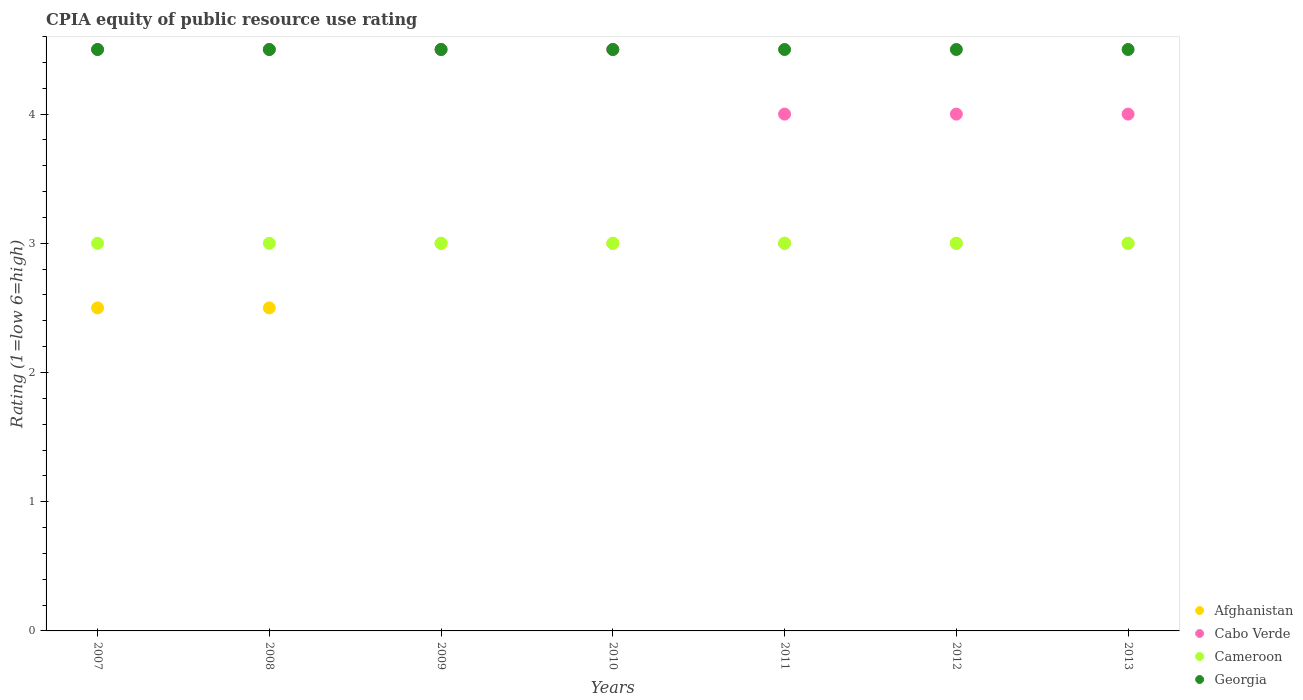How many different coloured dotlines are there?
Keep it short and to the point. 4. What is the CPIA rating in Cameroon in 2012?
Give a very brief answer. 3. Across all years, what is the minimum CPIA rating in Cabo Verde?
Keep it short and to the point. 4. In which year was the CPIA rating in Cameroon maximum?
Your answer should be compact. 2007. In which year was the CPIA rating in Afghanistan minimum?
Provide a short and direct response. 2007. What is the total CPIA rating in Afghanistan in the graph?
Your answer should be very brief. 20. What is the difference between the CPIA rating in Georgia in 2009 and that in 2010?
Your answer should be compact. 0. In the year 2007, what is the difference between the CPIA rating in Georgia and CPIA rating in Cabo Verde?
Give a very brief answer. 0. In how many years, is the CPIA rating in Cameroon greater than 3?
Your response must be concise. 0. What is the ratio of the CPIA rating in Cabo Verde in 2007 to that in 2011?
Provide a succinct answer. 1.12. Is the CPIA rating in Afghanistan in 2009 less than that in 2012?
Provide a succinct answer. No. What is the difference between the highest and the lowest CPIA rating in Cameroon?
Provide a succinct answer. 0. Is it the case that in every year, the sum of the CPIA rating in Cameroon and CPIA rating in Afghanistan  is greater than the CPIA rating in Georgia?
Ensure brevity in your answer.  Yes. Does the CPIA rating in Cameroon monotonically increase over the years?
Your answer should be very brief. No. Is the CPIA rating in Afghanistan strictly less than the CPIA rating in Cabo Verde over the years?
Your answer should be compact. Yes. How many dotlines are there?
Your answer should be compact. 4. How many years are there in the graph?
Make the answer very short. 7. Are the values on the major ticks of Y-axis written in scientific E-notation?
Make the answer very short. No. Does the graph contain any zero values?
Give a very brief answer. No. Does the graph contain grids?
Your answer should be very brief. No. Where does the legend appear in the graph?
Your answer should be very brief. Bottom right. How many legend labels are there?
Your answer should be compact. 4. How are the legend labels stacked?
Offer a very short reply. Vertical. What is the title of the graph?
Provide a short and direct response. CPIA equity of public resource use rating. What is the label or title of the X-axis?
Give a very brief answer. Years. What is the label or title of the Y-axis?
Ensure brevity in your answer.  Rating (1=low 6=high). What is the Rating (1=low 6=high) in Georgia in 2008?
Offer a very short reply. 4.5. What is the Rating (1=low 6=high) in Cabo Verde in 2009?
Provide a succinct answer. 4.5. What is the Rating (1=low 6=high) of Cameroon in 2009?
Give a very brief answer. 3. What is the Rating (1=low 6=high) in Afghanistan in 2010?
Offer a very short reply. 3. What is the Rating (1=low 6=high) of Cameroon in 2010?
Keep it short and to the point. 3. What is the Rating (1=low 6=high) of Cameroon in 2011?
Ensure brevity in your answer.  3. What is the Rating (1=low 6=high) in Cabo Verde in 2012?
Offer a terse response. 4. What is the Rating (1=low 6=high) of Georgia in 2012?
Ensure brevity in your answer.  4.5. What is the Rating (1=low 6=high) in Afghanistan in 2013?
Offer a terse response. 3. What is the Rating (1=low 6=high) in Cabo Verde in 2013?
Offer a terse response. 4. What is the Rating (1=low 6=high) of Cameroon in 2013?
Keep it short and to the point. 3. Across all years, what is the maximum Rating (1=low 6=high) in Cabo Verde?
Offer a terse response. 4.5. Across all years, what is the maximum Rating (1=low 6=high) of Georgia?
Your response must be concise. 4.5. Across all years, what is the minimum Rating (1=low 6=high) in Georgia?
Offer a terse response. 4.5. What is the total Rating (1=low 6=high) in Cabo Verde in the graph?
Ensure brevity in your answer.  30. What is the total Rating (1=low 6=high) of Cameroon in the graph?
Your response must be concise. 21. What is the total Rating (1=low 6=high) in Georgia in the graph?
Provide a succinct answer. 31.5. What is the difference between the Rating (1=low 6=high) in Afghanistan in 2007 and that in 2008?
Provide a short and direct response. 0. What is the difference between the Rating (1=low 6=high) in Cabo Verde in 2007 and that in 2008?
Provide a succinct answer. 0. What is the difference between the Rating (1=low 6=high) in Cameroon in 2007 and that in 2008?
Offer a terse response. 0. What is the difference between the Rating (1=low 6=high) in Cabo Verde in 2007 and that in 2009?
Offer a terse response. 0. What is the difference between the Rating (1=low 6=high) of Cabo Verde in 2007 and that in 2010?
Provide a succinct answer. 0. What is the difference between the Rating (1=low 6=high) of Afghanistan in 2007 and that in 2011?
Your response must be concise. -0.5. What is the difference between the Rating (1=low 6=high) of Cameroon in 2007 and that in 2011?
Ensure brevity in your answer.  0. What is the difference between the Rating (1=low 6=high) of Georgia in 2007 and that in 2012?
Your response must be concise. 0. What is the difference between the Rating (1=low 6=high) in Cameroon in 2007 and that in 2013?
Your answer should be compact. 0. What is the difference between the Rating (1=low 6=high) of Georgia in 2007 and that in 2013?
Offer a very short reply. 0. What is the difference between the Rating (1=low 6=high) in Afghanistan in 2008 and that in 2009?
Your response must be concise. -0.5. What is the difference between the Rating (1=low 6=high) in Cameroon in 2008 and that in 2009?
Make the answer very short. 0. What is the difference between the Rating (1=low 6=high) in Cabo Verde in 2008 and that in 2010?
Ensure brevity in your answer.  0. What is the difference between the Rating (1=low 6=high) of Georgia in 2008 and that in 2010?
Provide a short and direct response. 0. What is the difference between the Rating (1=low 6=high) of Afghanistan in 2008 and that in 2011?
Offer a terse response. -0.5. What is the difference between the Rating (1=low 6=high) of Georgia in 2008 and that in 2011?
Give a very brief answer. 0. What is the difference between the Rating (1=low 6=high) of Afghanistan in 2008 and that in 2012?
Give a very brief answer. -0.5. What is the difference between the Rating (1=low 6=high) of Cabo Verde in 2008 and that in 2012?
Provide a short and direct response. 0.5. What is the difference between the Rating (1=low 6=high) of Afghanistan in 2008 and that in 2013?
Your response must be concise. -0.5. What is the difference between the Rating (1=low 6=high) of Cabo Verde in 2008 and that in 2013?
Give a very brief answer. 0.5. What is the difference between the Rating (1=low 6=high) in Georgia in 2008 and that in 2013?
Give a very brief answer. 0. What is the difference between the Rating (1=low 6=high) in Cameroon in 2009 and that in 2010?
Provide a short and direct response. 0. What is the difference between the Rating (1=low 6=high) of Georgia in 2009 and that in 2010?
Ensure brevity in your answer.  0. What is the difference between the Rating (1=low 6=high) of Afghanistan in 2009 and that in 2011?
Offer a very short reply. 0. What is the difference between the Rating (1=low 6=high) in Afghanistan in 2009 and that in 2012?
Provide a short and direct response. 0. What is the difference between the Rating (1=low 6=high) of Cabo Verde in 2009 and that in 2012?
Make the answer very short. 0.5. What is the difference between the Rating (1=low 6=high) of Cameroon in 2009 and that in 2012?
Offer a terse response. 0. What is the difference between the Rating (1=low 6=high) in Georgia in 2009 and that in 2012?
Offer a terse response. 0. What is the difference between the Rating (1=low 6=high) in Afghanistan in 2009 and that in 2013?
Your answer should be very brief. 0. What is the difference between the Rating (1=low 6=high) of Cabo Verde in 2009 and that in 2013?
Give a very brief answer. 0.5. What is the difference between the Rating (1=low 6=high) of Cabo Verde in 2010 and that in 2011?
Provide a succinct answer. 0.5. What is the difference between the Rating (1=low 6=high) of Cameroon in 2010 and that in 2011?
Your answer should be compact. 0. What is the difference between the Rating (1=low 6=high) in Georgia in 2010 and that in 2011?
Your answer should be very brief. 0. What is the difference between the Rating (1=low 6=high) of Cabo Verde in 2010 and that in 2012?
Offer a very short reply. 0.5. What is the difference between the Rating (1=low 6=high) in Cameroon in 2010 and that in 2012?
Offer a terse response. 0. What is the difference between the Rating (1=low 6=high) in Georgia in 2010 and that in 2012?
Your answer should be very brief. 0. What is the difference between the Rating (1=low 6=high) of Afghanistan in 2010 and that in 2013?
Provide a succinct answer. 0. What is the difference between the Rating (1=low 6=high) of Cabo Verde in 2010 and that in 2013?
Your response must be concise. 0.5. What is the difference between the Rating (1=low 6=high) of Cameroon in 2010 and that in 2013?
Keep it short and to the point. 0. What is the difference between the Rating (1=low 6=high) in Cameroon in 2011 and that in 2012?
Your answer should be very brief. 0. What is the difference between the Rating (1=low 6=high) of Afghanistan in 2011 and that in 2013?
Keep it short and to the point. 0. What is the difference between the Rating (1=low 6=high) in Cabo Verde in 2011 and that in 2013?
Provide a succinct answer. 0. What is the difference between the Rating (1=low 6=high) in Georgia in 2011 and that in 2013?
Ensure brevity in your answer.  0. What is the difference between the Rating (1=low 6=high) of Cameroon in 2012 and that in 2013?
Offer a terse response. 0. What is the difference between the Rating (1=low 6=high) of Afghanistan in 2007 and the Rating (1=low 6=high) of Cameroon in 2008?
Your answer should be very brief. -0.5. What is the difference between the Rating (1=low 6=high) in Cabo Verde in 2007 and the Rating (1=low 6=high) in Cameroon in 2008?
Keep it short and to the point. 1.5. What is the difference between the Rating (1=low 6=high) in Cabo Verde in 2007 and the Rating (1=low 6=high) in Georgia in 2008?
Your answer should be compact. 0. What is the difference between the Rating (1=low 6=high) in Afghanistan in 2007 and the Rating (1=low 6=high) in Cameroon in 2009?
Provide a succinct answer. -0.5. What is the difference between the Rating (1=low 6=high) of Afghanistan in 2007 and the Rating (1=low 6=high) of Georgia in 2009?
Your response must be concise. -2. What is the difference between the Rating (1=low 6=high) in Cabo Verde in 2007 and the Rating (1=low 6=high) in Cameroon in 2009?
Offer a terse response. 1.5. What is the difference between the Rating (1=low 6=high) in Cameroon in 2007 and the Rating (1=low 6=high) in Georgia in 2009?
Offer a terse response. -1.5. What is the difference between the Rating (1=low 6=high) of Afghanistan in 2007 and the Rating (1=low 6=high) of Georgia in 2010?
Offer a very short reply. -2. What is the difference between the Rating (1=low 6=high) in Cabo Verde in 2007 and the Rating (1=low 6=high) in Georgia in 2010?
Offer a terse response. 0. What is the difference between the Rating (1=low 6=high) of Afghanistan in 2007 and the Rating (1=low 6=high) of Cabo Verde in 2011?
Provide a short and direct response. -1.5. What is the difference between the Rating (1=low 6=high) in Afghanistan in 2007 and the Rating (1=low 6=high) in Cameroon in 2011?
Offer a very short reply. -0.5. What is the difference between the Rating (1=low 6=high) of Afghanistan in 2007 and the Rating (1=low 6=high) of Georgia in 2011?
Offer a terse response. -2. What is the difference between the Rating (1=low 6=high) of Cabo Verde in 2007 and the Rating (1=low 6=high) of Cameroon in 2011?
Make the answer very short. 1.5. What is the difference between the Rating (1=low 6=high) of Cabo Verde in 2007 and the Rating (1=low 6=high) of Georgia in 2011?
Make the answer very short. 0. What is the difference between the Rating (1=low 6=high) of Afghanistan in 2007 and the Rating (1=low 6=high) of Cabo Verde in 2012?
Keep it short and to the point. -1.5. What is the difference between the Rating (1=low 6=high) in Cabo Verde in 2007 and the Rating (1=low 6=high) in Cameroon in 2012?
Your response must be concise. 1.5. What is the difference between the Rating (1=low 6=high) in Cabo Verde in 2007 and the Rating (1=low 6=high) in Georgia in 2012?
Give a very brief answer. 0. What is the difference between the Rating (1=low 6=high) of Afghanistan in 2007 and the Rating (1=low 6=high) of Cabo Verde in 2013?
Ensure brevity in your answer.  -1.5. What is the difference between the Rating (1=low 6=high) in Cabo Verde in 2007 and the Rating (1=low 6=high) in Georgia in 2013?
Your answer should be very brief. 0. What is the difference between the Rating (1=low 6=high) in Afghanistan in 2008 and the Rating (1=low 6=high) in Cameroon in 2009?
Ensure brevity in your answer.  -0.5. What is the difference between the Rating (1=low 6=high) in Cabo Verde in 2008 and the Rating (1=low 6=high) in Georgia in 2009?
Your answer should be compact. 0. What is the difference between the Rating (1=low 6=high) in Cameroon in 2008 and the Rating (1=low 6=high) in Georgia in 2009?
Make the answer very short. -1.5. What is the difference between the Rating (1=low 6=high) of Afghanistan in 2008 and the Rating (1=low 6=high) of Cameroon in 2010?
Offer a very short reply. -0.5. What is the difference between the Rating (1=low 6=high) of Afghanistan in 2008 and the Rating (1=low 6=high) of Georgia in 2010?
Give a very brief answer. -2. What is the difference between the Rating (1=low 6=high) of Cabo Verde in 2008 and the Rating (1=low 6=high) of Georgia in 2010?
Keep it short and to the point. 0. What is the difference between the Rating (1=low 6=high) in Cameroon in 2008 and the Rating (1=low 6=high) in Georgia in 2010?
Make the answer very short. -1.5. What is the difference between the Rating (1=low 6=high) in Afghanistan in 2008 and the Rating (1=low 6=high) in Cabo Verde in 2011?
Your response must be concise. -1.5. What is the difference between the Rating (1=low 6=high) of Cabo Verde in 2008 and the Rating (1=low 6=high) of Cameroon in 2011?
Make the answer very short. 1.5. What is the difference between the Rating (1=low 6=high) in Cabo Verde in 2008 and the Rating (1=low 6=high) in Cameroon in 2012?
Offer a terse response. 1.5. What is the difference between the Rating (1=low 6=high) in Cameroon in 2008 and the Rating (1=low 6=high) in Georgia in 2012?
Offer a terse response. -1.5. What is the difference between the Rating (1=low 6=high) of Afghanistan in 2008 and the Rating (1=low 6=high) of Cabo Verde in 2013?
Your answer should be very brief. -1.5. What is the difference between the Rating (1=low 6=high) of Cabo Verde in 2008 and the Rating (1=low 6=high) of Cameroon in 2013?
Your response must be concise. 1.5. What is the difference between the Rating (1=low 6=high) of Cameroon in 2008 and the Rating (1=low 6=high) of Georgia in 2013?
Provide a succinct answer. -1.5. What is the difference between the Rating (1=low 6=high) in Afghanistan in 2009 and the Rating (1=low 6=high) in Cabo Verde in 2010?
Your answer should be compact. -1.5. What is the difference between the Rating (1=low 6=high) in Afghanistan in 2009 and the Rating (1=low 6=high) in Cameroon in 2010?
Give a very brief answer. 0. What is the difference between the Rating (1=low 6=high) of Afghanistan in 2009 and the Rating (1=low 6=high) of Georgia in 2010?
Make the answer very short. -1.5. What is the difference between the Rating (1=low 6=high) of Cabo Verde in 2009 and the Rating (1=low 6=high) of Cameroon in 2010?
Provide a succinct answer. 1.5. What is the difference between the Rating (1=low 6=high) in Afghanistan in 2009 and the Rating (1=low 6=high) in Cabo Verde in 2011?
Provide a short and direct response. -1. What is the difference between the Rating (1=low 6=high) in Afghanistan in 2009 and the Rating (1=low 6=high) in Cameroon in 2011?
Your answer should be very brief. 0. What is the difference between the Rating (1=low 6=high) of Afghanistan in 2009 and the Rating (1=low 6=high) of Georgia in 2011?
Ensure brevity in your answer.  -1.5. What is the difference between the Rating (1=low 6=high) in Cabo Verde in 2009 and the Rating (1=low 6=high) in Cameroon in 2011?
Provide a short and direct response. 1.5. What is the difference between the Rating (1=low 6=high) in Cameroon in 2009 and the Rating (1=low 6=high) in Georgia in 2011?
Keep it short and to the point. -1.5. What is the difference between the Rating (1=low 6=high) of Cabo Verde in 2009 and the Rating (1=low 6=high) of Cameroon in 2012?
Give a very brief answer. 1.5. What is the difference between the Rating (1=low 6=high) of Afghanistan in 2009 and the Rating (1=low 6=high) of Georgia in 2013?
Your response must be concise. -1.5. What is the difference between the Rating (1=low 6=high) in Afghanistan in 2010 and the Rating (1=low 6=high) in Cameroon in 2011?
Provide a succinct answer. 0. What is the difference between the Rating (1=low 6=high) in Afghanistan in 2010 and the Rating (1=low 6=high) in Cabo Verde in 2012?
Your answer should be compact. -1. What is the difference between the Rating (1=low 6=high) in Afghanistan in 2010 and the Rating (1=low 6=high) in Cameroon in 2012?
Your response must be concise. 0. What is the difference between the Rating (1=low 6=high) in Afghanistan in 2010 and the Rating (1=low 6=high) in Georgia in 2012?
Provide a succinct answer. -1.5. What is the difference between the Rating (1=low 6=high) of Cabo Verde in 2010 and the Rating (1=low 6=high) of Cameroon in 2012?
Make the answer very short. 1.5. What is the difference between the Rating (1=low 6=high) in Cameroon in 2010 and the Rating (1=low 6=high) in Georgia in 2012?
Offer a very short reply. -1.5. What is the difference between the Rating (1=low 6=high) of Afghanistan in 2010 and the Rating (1=low 6=high) of Cameroon in 2013?
Your answer should be compact. 0. What is the difference between the Rating (1=low 6=high) in Cabo Verde in 2010 and the Rating (1=low 6=high) in Cameroon in 2013?
Your answer should be very brief. 1.5. What is the difference between the Rating (1=low 6=high) of Afghanistan in 2011 and the Rating (1=low 6=high) of Cabo Verde in 2012?
Provide a succinct answer. -1. What is the difference between the Rating (1=low 6=high) in Cabo Verde in 2011 and the Rating (1=low 6=high) in Cameroon in 2012?
Provide a succinct answer. 1. What is the difference between the Rating (1=low 6=high) of Afghanistan in 2011 and the Rating (1=low 6=high) of Georgia in 2013?
Offer a terse response. -1.5. What is the difference between the Rating (1=low 6=high) in Cabo Verde in 2011 and the Rating (1=low 6=high) in Cameroon in 2013?
Ensure brevity in your answer.  1. What is the difference between the Rating (1=low 6=high) of Cabo Verde in 2011 and the Rating (1=low 6=high) of Georgia in 2013?
Offer a terse response. -0.5. What is the difference between the Rating (1=low 6=high) of Afghanistan in 2012 and the Rating (1=low 6=high) of Cabo Verde in 2013?
Your response must be concise. -1. What is the difference between the Rating (1=low 6=high) in Cabo Verde in 2012 and the Rating (1=low 6=high) in Cameroon in 2013?
Give a very brief answer. 1. What is the difference between the Rating (1=low 6=high) of Cabo Verde in 2012 and the Rating (1=low 6=high) of Georgia in 2013?
Your answer should be very brief. -0.5. What is the difference between the Rating (1=low 6=high) of Cameroon in 2012 and the Rating (1=low 6=high) of Georgia in 2013?
Your answer should be very brief. -1.5. What is the average Rating (1=low 6=high) in Afghanistan per year?
Offer a very short reply. 2.86. What is the average Rating (1=low 6=high) of Cabo Verde per year?
Ensure brevity in your answer.  4.29. What is the average Rating (1=low 6=high) in Cameroon per year?
Your response must be concise. 3. What is the average Rating (1=low 6=high) of Georgia per year?
Give a very brief answer. 4.5. In the year 2007, what is the difference between the Rating (1=low 6=high) in Afghanistan and Rating (1=low 6=high) in Cabo Verde?
Your answer should be compact. -2. In the year 2007, what is the difference between the Rating (1=low 6=high) in Cabo Verde and Rating (1=low 6=high) in Cameroon?
Keep it short and to the point. 1.5. In the year 2007, what is the difference between the Rating (1=low 6=high) in Cabo Verde and Rating (1=low 6=high) in Georgia?
Your answer should be compact. 0. In the year 2007, what is the difference between the Rating (1=low 6=high) of Cameroon and Rating (1=low 6=high) of Georgia?
Ensure brevity in your answer.  -1.5. In the year 2008, what is the difference between the Rating (1=low 6=high) of Afghanistan and Rating (1=low 6=high) of Cameroon?
Offer a terse response. -0.5. In the year 2008, what is the difference between the Rating (1=low 6=high) of Afghanistan and Rating (1=low 6=high) of Georgia?
Provide a short and direct response. -2. In the year 2008, what is the difference between the Rating (1=low 6=high) in Cabo Verde and Rating (1=low 6=high) in Georgia?
Your response must be concise. 0. In the year 2008, what is the difference between the Rating (1=low 6=high) of Cameroon and Rating (1=low 6=high) of Georgia?
Your answer should be very brief. -1.5. In the year 2009, what is the difference between the Rating (1=low 6=high) of Afghanistan and Rating (1=low 6=high) of Cabo Verde?
Keep it short and to the point. -1.5. In the year 2009, what is the difference between the Rating (1=low 6=high) of Afghanistan and Rating (1=low 6=high) of Cameroon?
Your answer should be compact. 0. In the year 2009, what is the difference between the Rating (1=low 6=high) of Cabo Verde and Rating (1=low 6=high) of Cameroon?
Ensure brevity in your answer.  1.5. In the year 2010, what is the difference between the Rating (1=low 6=high) of Afghanistan and Rating (1=low 6=high) of Georgia?
Provide a short and direct response. -1.5. In the year 2010, what is the difference between the Rating (1=low 6=high) of Cabo Verde and Rating (1=low 6=high) of Georgia?
Provide a short and direct response. 0. In the year 2011, what is the difference between the Rating (1=low 6=high) in Afghanistan and Rating (1=low 6=high) in Cabo Verde?
Give a very brief answer. -1. In the year 2011, what is the difference between the Rating (1=low 6=high) in Cabo Verde and Rating (1=low 6=high) in Cameroon?
Make the answer very short. 1. In the year 2011, what is the difference between the Rating (1=low 6=high) in Cabo Verde and Rating (1=low 6=high) in Georgia?
Provide a succinct answer. -0.5. In the year 2011, what is the difference between the Rating (1=low 6=high) of Cameroon and Rating (1=low 6=high) of Georgia?
Your response must be concise. -1.5. In the year 2012, what is the difference between the Rating (1=low 6=high) in Afghanistan and Rating (1=low 6=high) in Cabo Verde?
Provide a short and direct response. -1. In the year 2013, what is the difference between the Rating (1=low 6=high) of Afghanistan and Rating (1=low 6=high) of Cabo Verde?
Your response must be concise. -1. In the year 2013, what is the difference between the Rating (1=low 6=high) in Afghanistan and Rating (1=low 6=high) in Cameroon?
Provide a succinct answer. 0. In the year 2013, what is the difference between the Rating (1=low 6=high) of Afghanistan and Rating (1=low 6=high) of Georgia?
Your answer should be very brief. -1.5. In the year 2013, what is the difference between the Rating (1=low 6=high) of Cabo Verde and Rating (1=low 6=high) of Georgia?
Your answer should be compact. -0.5. What is the ratio of the Rating (1=low 6=high) of Afghanistan in 2007 to that in 2008?
Provide a succinct answer. 1. What is the ratio of the Rating (1=low 6=high) of Cabo Verde in 2007 to that in 2009?
Give a very brief answer. 1. What is the ratio of the Rating (1=low 6=high) of Afghanistan in 2007 to that in 2010?
Give a very brief answer. 0.83. What is the ratio of the Rating (1=low 6=high) in Georgia in 2007 to that in 2010?
Give a very brief answer. 1. What is the ratio of the Rating (1=low 6=high) in Cabo Verde in 2007 to that in 2011?
Provide a short and direct response. 1.12. What is the ratio of the Rating (1=low 6=high) of Cameroon in 2007 to that in 2011?
Offer a terse response. 1. What is the ratio of the Rating (1=low 6=high) of Afghanistan in 2007 to that in 2012?
Give a very brief answer. 0.83. What is the ratio of the Rating (1=low 6=high) in Cabo Verde in 2007 to that in 2012?
Make the answer very short. 1.12. What is the ratio of the Rating (1=low 6=high) of Georgia in 2007 to that in 2012?
Provide a short and direct response. 1. What is the ratio of the Rating (1=low 6=high) of Afghanistan in 2007 to that in 2013?
Ensure brevity in your answer.  0.83. What is the ratio of the Rating (1=low 6=high) of Cabo Verde in 2007 to that in 2013?
Your answer should be compact. 1.12. What is the ratio of the Rating (1=low 6=high) of Georgia in 2007 to that in 2013?
Make the answer very short. 1. What is the ratio of the Rating (1=low 6=high) of Afghanistan in 2008 to that in 2009?
Keep it short and to the point. 0.83. What is the ratio of the Rating (1=low 6=high) in Cabo Verde in 2008 to that in 2009?
Offer a terse response. 1. What is the ratio of the Rating (1=low 6=high) in Georgia in 2008 to that in 2009?
Provide a short and direct response. 1. What is the ratio of the Rating (1=low 6=high) in Cabo Verde in 2008 to that in 2010?
Give a very brief answer. 1. What is the ratio of the Rating (1=low 6=high) of Georgia in 2008 to that in 2010?
Ensure brevity in your answer.  1. What is the ratio of the Rating (1=low 6=high) of Afghanistan in 2008 to that in 2011?
Offer a very short reply. 0.83. What is the ratio of the Rating (1=low 6=high) of Cabo Verde in 2008 to that in 2011?
Make the answer very short. 1.12. What is the ratio of the Rating (1=low 6=high) in Afghanistan in 2008 to that in 2012?
Ensure brevity in your answer.  0.83. What is the ratio of the Rating (1=low 6=high) of Cabo Verde in 2008 to that in 2012?
Give a very brief answer. 1.12. What is the ratio of the Rating (1=low 6=high) of Cameroon in 2008 to that in 2012?
Ensure brevity in your answer.  1. What is the ratio of the Rating (1=low 6=high) in Afghanistan in 2008 to that in 2013?
Ensure brevity in your answer.  0.83. What is the ratio of the Rating (1=low 6=high) of Cabo Verde in 2008 to that in 2013?
Offer a terse response. 1.12. What is the ratio of the Rating (1=low 6=high) of Cameroon in 2008 to that in 2013?
Ensure brevity in your answer.  1. What is the ratio of the Rating (1=low 6=high) in Georgia in 2008 to that in 2013?
Your answer should be very brief. 1. What is the ratio of the Rating (1=low 6=high) in Afghanistan in 2009 to that in 2010?
Make the answer very short. 1. What is the ratio of the Rating (1=low 6=high) in Cameroon in 2009 to that in 2010?
Give a very brief answer. 1. What is the ratio of the Rating (1=low 6=high) in Georgia in 2009 to that in 2010?
Keep it short and to the point. 1. What is the ratio of the Rating (1=low 6=high) of Cabo Verde in 2009 to that in 2011?
Make the answer very short. 1.12. What is the ratio of the Rating (1=low 6=high) in Afghanistan in 2009 to that in 2012?
Offer a very short reply. 1. What is the ratio of the Rating (1=low 6=high) of Cabo Verde in 2009 to that in 2012?
Your answer should be very brief. 1.12. What is the ratio of the Rating (1=low 6=high) of Georgia in 2009 to that in 2012?
Provide a short and direct response. 1. What is the ratio of the Rating (1=low 6=high) of Afghanistan in 2009 to that in 2013?
Provide a short and direct response. 1. What is the ratio of the Rating (1=low 6=high) in Cameroon in 2009 to that in 2013?
Offer a very short reply. 1. What is the ratio of the Rating (1=low 6=high) in Cabo Verde in 2010 to that in 2011?
Offer a very short reply. 1.12. What is the ratio of the Rating (1=low 6=high) of Cameroon in 2010 to that in 2011?
Provide a short and direct response. 1. What is the ratio of the Rating (1=low 6=high) of Afghanistan in 2010 to that in 2012?
Provide a short and direct response. 1. What is the ratio of the Rating (1=low 6=high) of Cabo Verde in 2010 to that in 2012?
Offer a very short reply. 1.12. What is the ratio of the Rating (1=low 6=high) in Cameroon in 2010 to that in 2012?
Your answer should be very brief. 1. What is the ratio of the Rating (1=low 6=high) in Afghanistan in 2010 to that in 2013?
Offer a terse response. 1. What is the ratio of the Rating (1=low 6=high) in Cameroon in 2010 to that in 2013?
Offer a very short reply. 1. What is the ratio of the Rating (1=low 6=high) in Afghanistan in 2011 to that in 2012?
Provide a succinct answer. 1. What is the ratio of the Rating (1=low 6=high) of Georgia in 2011 to that in 2012?
Ensure brevity in your answer.  1. What is the ratio of the Rating (1=low 6=high) in Afghanistan in 2011 to that in 2013?
Your response must be concise. 1. What is the ratio of the Rating (1=low 6=high) of Afghanistan in 2012 to that in 2013?
Make the answer very short. 1. What is the ratio of the Rating (1=low 6=high) in Cabo Verde in 2012 to that in 2013?
Provide a short and direct response. 1. What is the ratio of the Rating (1=low 6=high) of Georgia in 2012 to that in 2013?
Offer a terse response. 1. What is the difference between the highest and the second highest Rating (1=low 6=high) in Cabo Verde?
Ensure brevity in your answer.  0. What is the difference between the highest and the lowest Rating (1=low 6=high) in Afghanistan?
Make the answer very short. 0.5. 